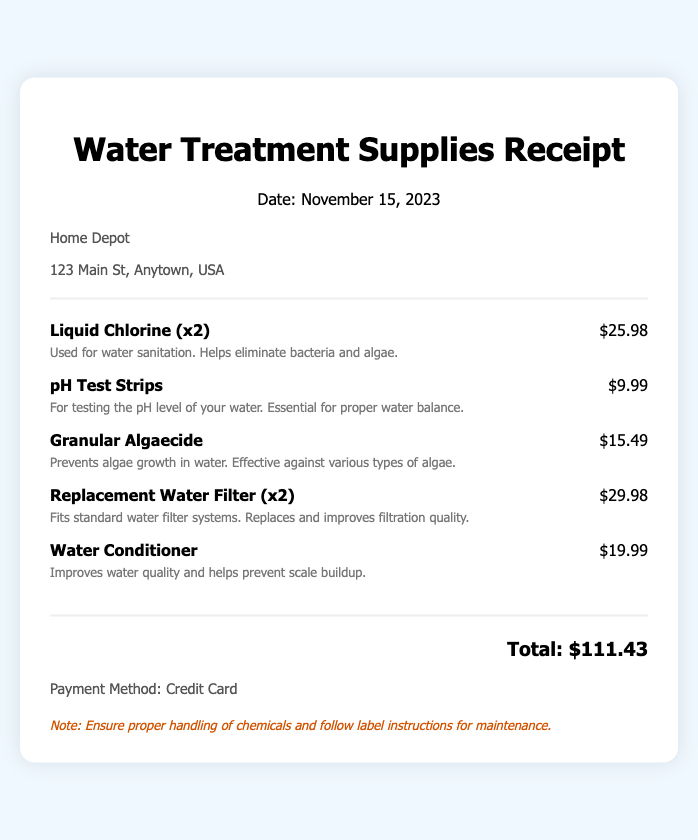what is the date of the receipt? The date of the receipt is mentioned in the header of the document, which is November 15, 2023.
Answer: November 15, 2023 what is the name of the store? The store's name is prominently displayed near the top of the document, which is Home Depot.
Answer: Home Depot how many Liquid Chlorine bottles were purchased? The quantity of Liquid Chlorine is specified as "x2" in the item description.
Answer: x2 what is the price of pH Test Strips? The price is listed next to the item, which is $9.99.
Answer: $9.99 what is the total amount spent? The total amount is calculated and displayed at the bottom of the receipt, which is $111.43.
Answer: $111.43 what payment method was used? The payment method is mentioned in the payment info section of the document, which is Credit Card.
Answer: Credit Card what is the function of Water Conditioner? The document describes the Water Conditioner as improving water quality and helping to prevent scale buildup.
Answer: Improves water quality and helps prevent scale buildup how many Replacement Water Filters were purchased? The quantity purchased is indicated as "x2" in the item description.
Answer: x2 what is noted regarding chemical handling? A note emphasizes the importance of ensuring proper handling and following label instructions for maintenance.
Answer: Ensure proper handling of chemicals and follow label instructions for maintenance 